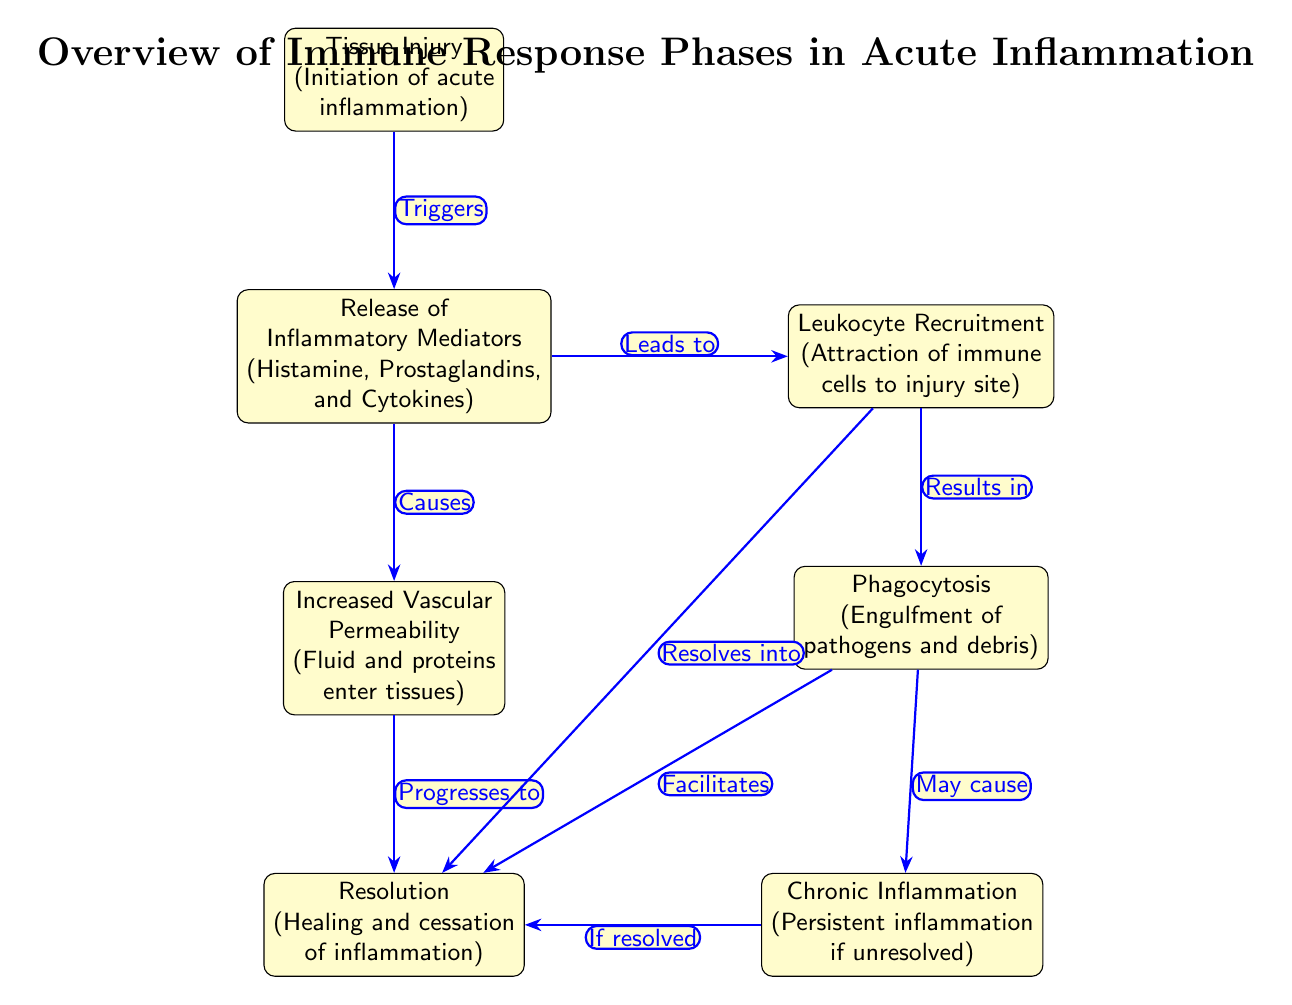What initiates acute inflammation? The diagram labels the first node as "Tissue Injury," which indicates that tissue injury is the initial trigger for acute inflammation.
Answer: Tissue Injury Which inflammatory mediators are released? The second node specifies that inflammatory mediators such as "Histamine, Prostaglandins, and Cytokines" are released during this phase.
Answer: Histamine, Prostaglandins, and Cytokines How many major phases are depicted in the diagram? By counting the nodes in the diagram, there are a total of six main phases outlined.
Answer: Six What causes increased vascular permeability? The diagram indicates that the "Release of Inflammatory Mediators" leads to increased vascular permeability, implying that the mediators are responsible for this effect.
Answer: Release of Inflammatory Mediators Which phase leads to phagocytosis? The diagram shows an arrow from "Leukocyte Recruitment" to "Phagocytosis," indicating that the recruitment of immune cells leads to this action.
Answer: Leukocyte Recruitment Which node represents the resolution of inflammation? The "Resolution" node, located below the increased vascular permeability and phagocytosis nodes, signifies the end phase of acute inflammation.
Answer: Resolution What happens if inflammation is unresolved? The last node connected to "Phagocytosis" indicates that chronic inflammation occurs if the resolution does not take place, showing the possibility of lingering inflammatory response.
Answer: Chronic Inflammation How do leukocyte recruitment and phagocytosis interrelate? The diagram shows that leukocyte recruitment results in phagocytosis, establishing a sequential relationship where the former is necessary for initiating the latter.
Answer: Results in What connects the phases of increased vascular permeability and resolution? Both nodes ("Increased Vascular Permeability" and "Resolution") are linked via the "Fluid and proteins enter tissues" concept, showing the transition from one to the other through their effects.
Answer: Increased Vascular Permeability What results from phagocytosis during inflammation? According to the diagram, the action of phagocytosis leads to the "Resolution" of inflammation, providing clarity about the end phase after immune response actions are taken.
Answer: Facilitates 